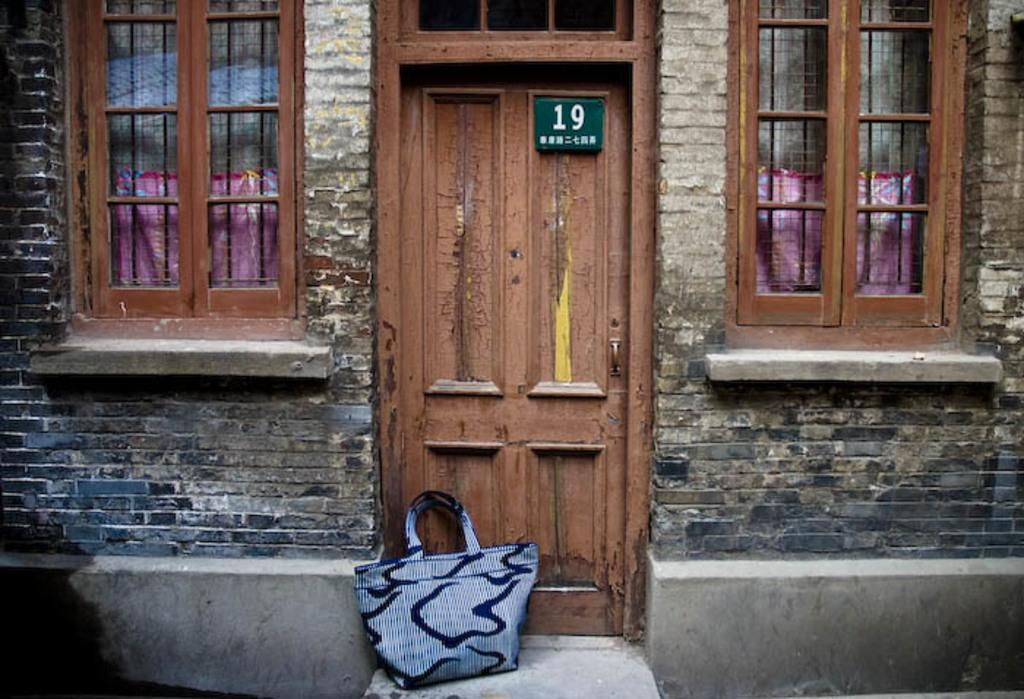What object is present in the image that people might use to carry items? There is a bag in the image. What type of structure can be seen in the image? There is a building in the image. What feature of the building is visible in the image? There is a door in the image. What architectural element allows light and air to enter the building in the image? There are windows in the image. How long does it take for the sun to pass through the minute in the image? There is no sun or minute hand present in the image, as it only features a bag, a building, a door, and windows. 